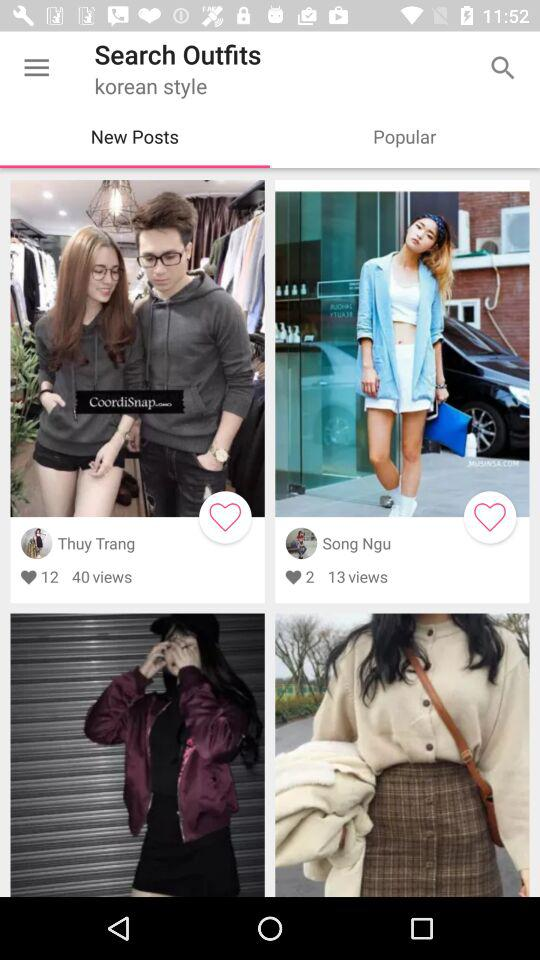Which post is liked by 2 people?
When the provided information is insufficient, respond with <no answer>. <no answer> 